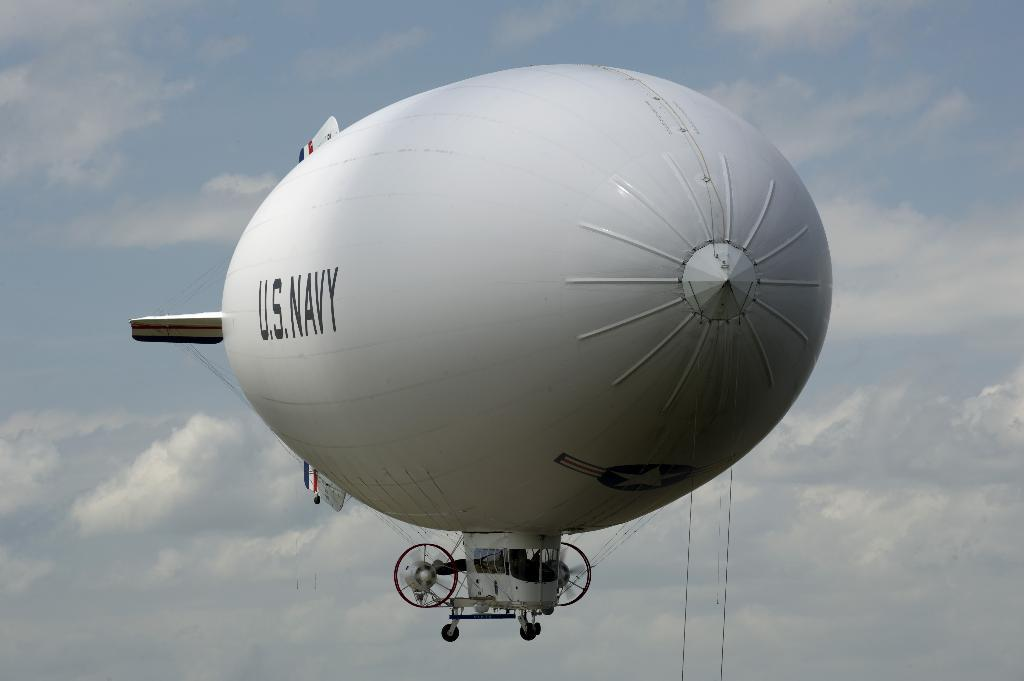Provide a one-sentence caption for the provided image. A large white blimp with U.S. Navy emblazoned along the side. 